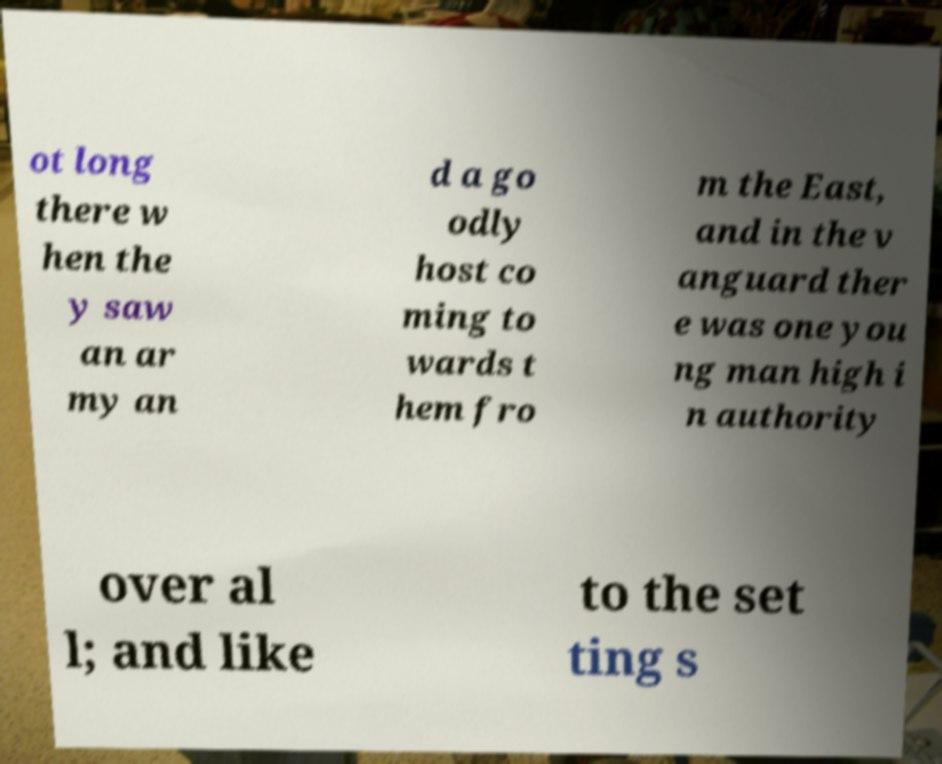What messages or text are displayed in this image? I need them in a readable, typed format. ot long there w hen the y saw an ar my an d a go odly host co ming to wards t hem fro m the East, and in the v anguard ther e was one you ng man high i n authority over al l; and like to the set ting s 